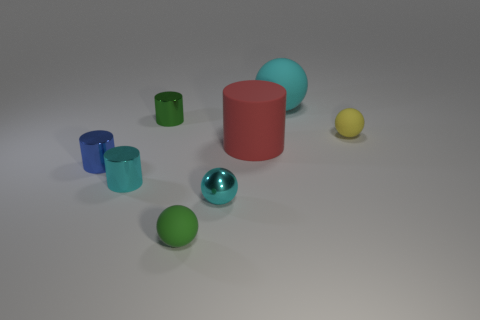There is a tiny blue cylinder that is on the left side of the green metallic cylinder; what is it made of?
Your response must be concise. Metal. How many small objects are either red matte things or rubber blocks?
Give a very brief answer. 0. Is the size of the cyan ball behind the green metallic thing the same as the big cylinder?
Offer a terse response. Yes. What number of other objects are there of the same color as the metallic sphere?
Keep it short and to the point. 2. What is the material of the big cyan thing?
Provide a succinct answer. Rubber. What is the small thing that is both behind the big cylinder and left of the large red cylinder made of?
Offer a terse response. Metal. How many things are either rubber things to the right of the green matte thing or red cylinders?
Give a very brief answer. 3. Do the small metallic sphere and the big matte ball have the same color?
Provide a short and direct response. Yes. Is there a red thing that has the same size as the cyan rubber sphere?
Offer a very short reply. Yes. What number of spheres are in front of the large matte ball and to the right of the big red cylinder?
Keep it short and to the point. 1. 